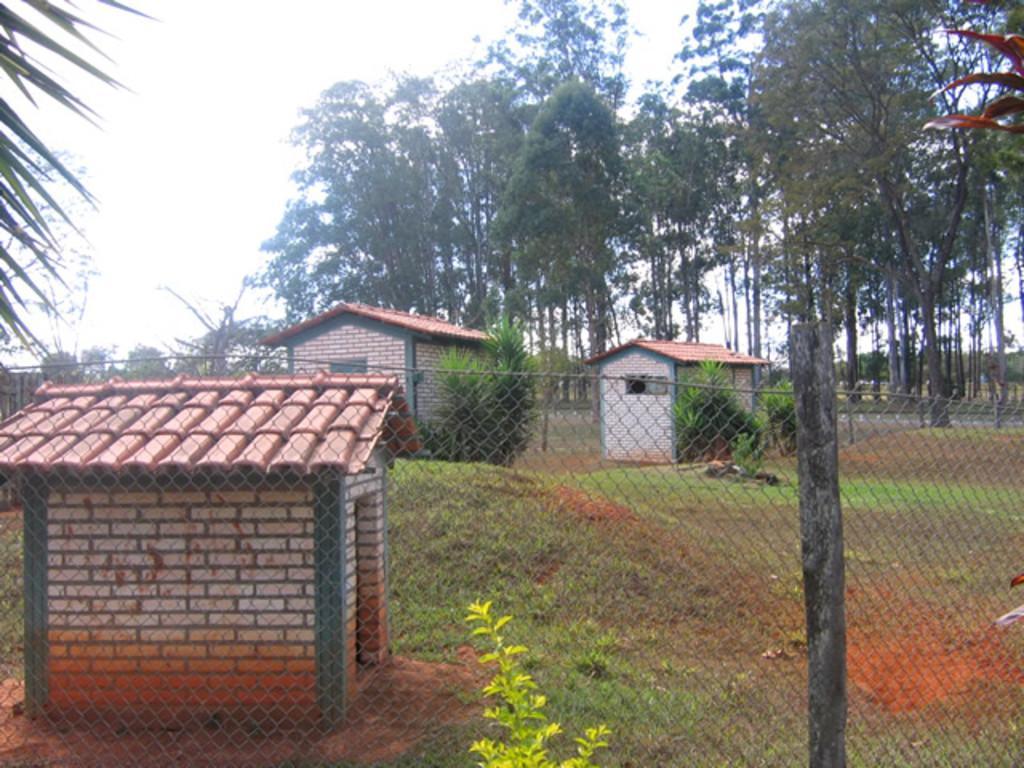How would you summarize this image in a sentence or two? This image is taken outdoors. At the top of the image there is the sky. In the background there are many trees and plants with leaves, stems and branches. In the middle of the image there are two houses. On the left side of the image there is a tree and there is a house. At the bottom of the image there is a fence. 